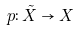<formula> <loc_0><loc_0><loc_500><loc_500>p \colon \tilde { X } \to X</formula> 